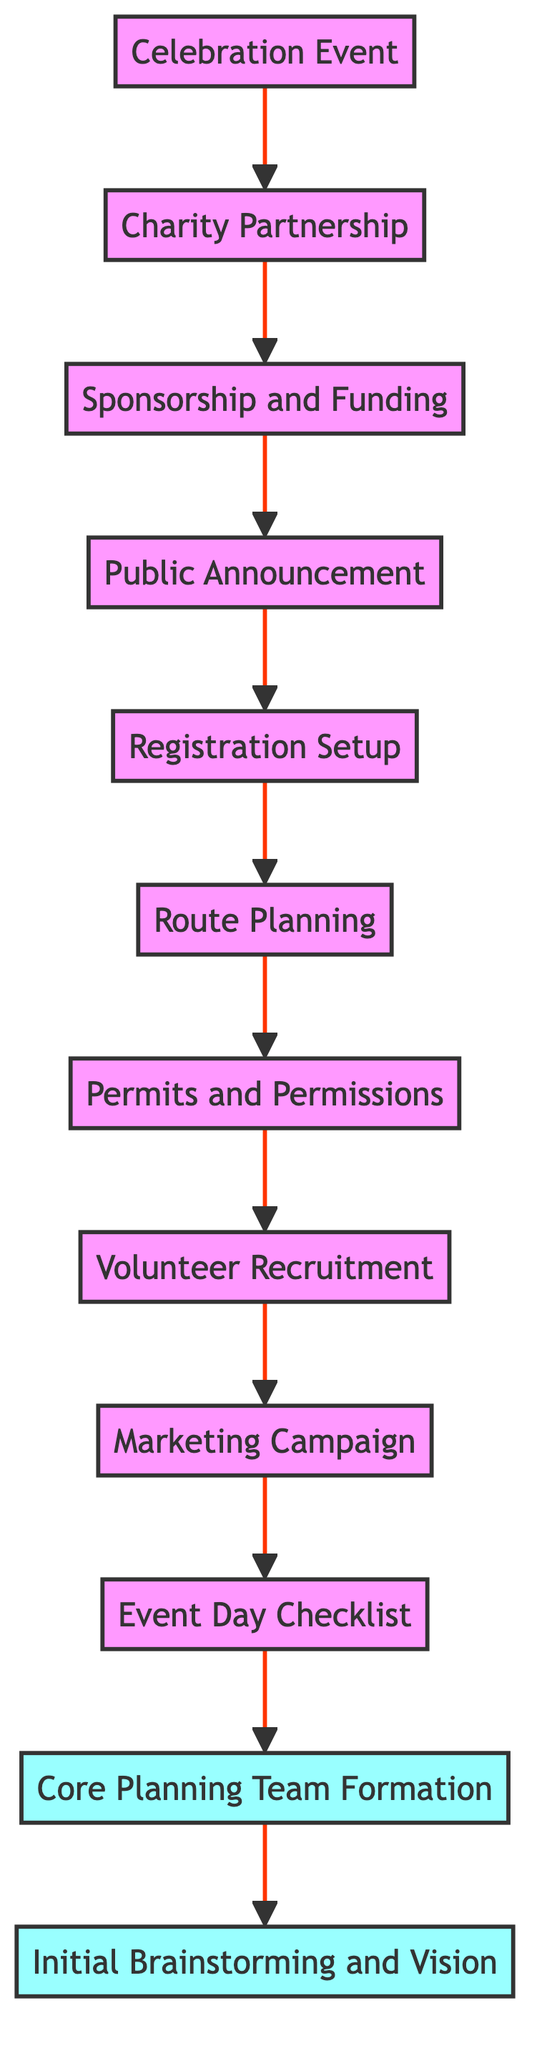What is the final step of the charity ride process? The final step is the "Celebration Event," which is the last node in the flowchart, signifying the event that concludes the charity ride in memory of Arturo.
Answer: Celebration Event How many nodes are present in the diagram? By counting each unique function or step listed in the diagram, there are a total of 12 nodes depicted in the flowchart.
Answer: 12 What is the relationship between "Public Announcement" and "Sponsorship and Funding"? "Public Announcement" is dependent on the completion of "Sponsorship and Funding," meaning "Public Announcement" can only occur after securing sponsorship.
Answer: "Public Announcement" depends on "Sponsorship and Funding" Which node must be completed first to initiate the charity ride? The initial task to start the process is "Initial Brainstorming and Vision," which is the first step in the flowchart and needs to be completed before any further actions can occur.
Answer: Initial Brainstorming and Vision What is the last step before the "Event Day Checklist"? The last step prior to the "Event Day Checklist" is the "Marketing Campaign," indicating that marketing must take place before creating a checklist for the day's event.
Answer: Marketing Campaign How many dependencies does "Charity Partnership" have? "Charity Partnership" relies on the completion of one prior node, which is the "Celebration Event," indicating it has a single dependency.
Answer: 1 What comes immediately after "Route Planning"? Following "Route Planning," there is the step for obtaining "Permits and Permissions," which directly depends on the successful planning of the route.
Answer: Permits and Permissions Which element is required to be set up after the "Public Announcement"? The next step following the "Public Announcement" is to set up "Registration Setup," highlighting the need for registration following the announcement of the charity ride.
Answer: Registration Setup 